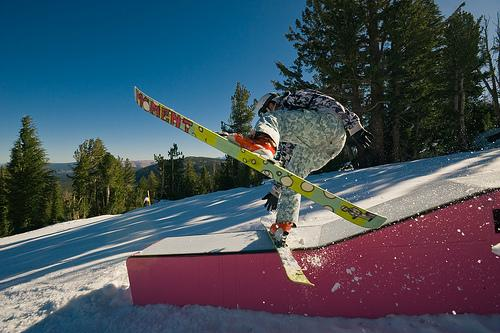What type of pants is the skier wearing and how do they look with the ski jacket? The skier is wearing camouflage pants, which look funny when paired with the ski jacket. Please provide a brief description of the landscape and mention the weather condition visible in the image. The image captures a snowy landscape with a skier, abundant evergreen trees, clear crystal blue sky, and deep snow on a mountain. Describe the overall appearance of the sky and any visible elements of weather. The sky is crystal clear blue, with no visible clouds or other weather elements. Describe the skier's pose and what it seems like they might be experiencing. The skier is lifting one leg in the air, looking like he is about to fall, and appears to be having trouble. State something unique about the design on the skier's equipment. The design on the skis is funny and appears to be very colorful. Describe the objects that the skier is wearing on their head and hands. The skier is wearing a helmet on their head and black gloves on their hands. What kind of trees are there in the image, and how would you describe their abundance? There are pine and evergreen trees on the mountain, and they are plentiful. Identify the main activity happening in the image and describe the clothing of the person involved. A man is performing a snow ski stunt while wearing camouflage pants, a helmet, gloves, and bright orange ski boots. Mention one prominent color near the trick platform and one prominent color on the skier's boots. The trick platform has a pink side, and the skier is wearing bright orange boots. Tell us about the skier's location and what they are doing. The skier is skiing down a snowy mountain at a resort, performing tricks and stunts. 